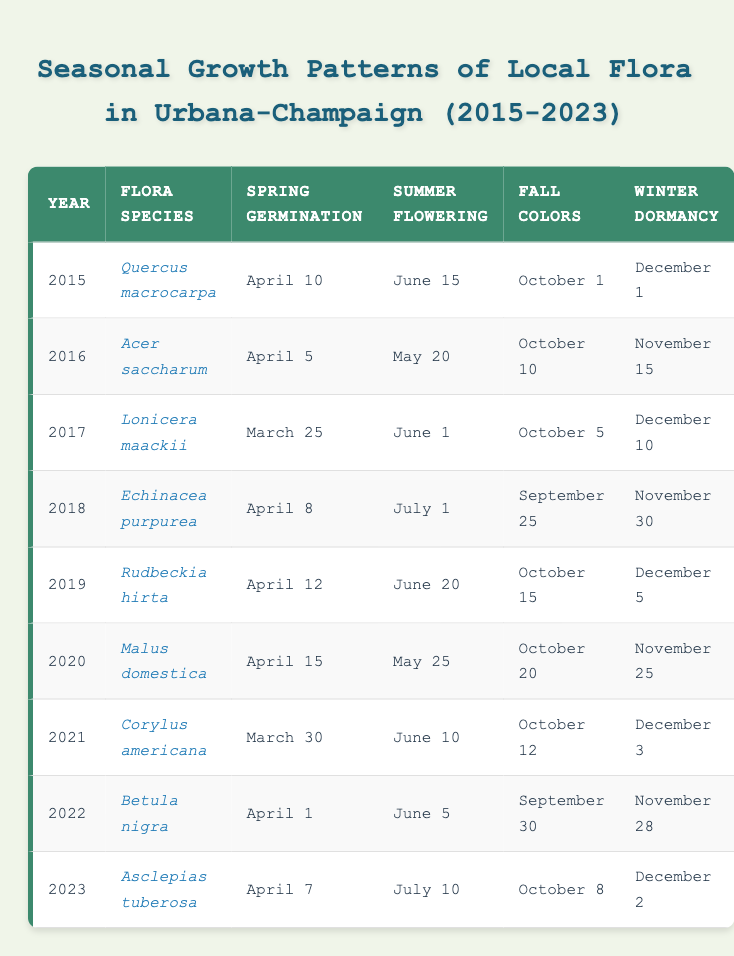What flora species had the earliest spring germination date? The table shows that "Lonicera maackii" germinated on March 25 in 2017, which is the earliest date listed for spring germination across the years.
Answer: Lonicera maackii In which year did "Echinacea purpurea" start flowering in summer? According to the table, "Echinacea purpurea" began summer flowering on July 1 in 2018, which is explicitly stated in the relevant row.
Answer: 2018 Which plant had the latest winter dormancy date? By reviewing the data, "Lonicera maackii" has the latest winter dormancy date stated as December 10 in 2017.
Answer: December 10 What is the average date for fall colors across all flora species? To find the average, convert the fall color dates to day of year: October 1 (274), October 10 (283), October 5 (278), September 25 (268), October 15 (288), October 20 (293), October 12 (285), September 30 (273), October 8 (281). The sum is 2537, and there are 9 entries, so 2537/9 results in an average day of 282. To find the corresponding date, day 282 is October 9.
Answer: October 9 Did any species have the same spring germination date? Reviewing the table shows no two species share the same spring germination date; each species has a unique date assigned each year.
Answer: No What is the difference in fall color dates between "Rudbeckia hirta" and "Malus domestica"? "Rudbeckia hirta" has a fall color date of October 15 (288) and "Malus domestica" has October 20 (293). The difference is 293 - 288 = 5 days.
Answer: 5 days Which species flowered in summer earliest among those listed? According to the table, "Acer saccharum" flowers earliest in the summer, blooming on May 20 in 2016. This is earlier than any other species shown.
Answer: Acer saccharum How many flora species had their fall colors before October 10? The species "Quercus macrocarpa", "Echinacea purpurea", "Rudbeckia hirta", "Corylus americana", and "Betula nigra" had their fall colors before October 10, totaling 5 species according to the fall color dates listed.
Answer: 5 species Which year had the most consequent flowering of flora species? By counting the flowering months in the summer, both 2017 ("Lonicera maackii" and 2018 ("Echinacea purpurea") had consecutive months. Since "Echinacea purpurea" blooms in July 1 after June, 2018 is the year with the longest consecutive flowering from June (Lonicera maackii) into July (Echinacea purpurea).
Answer: 2018 